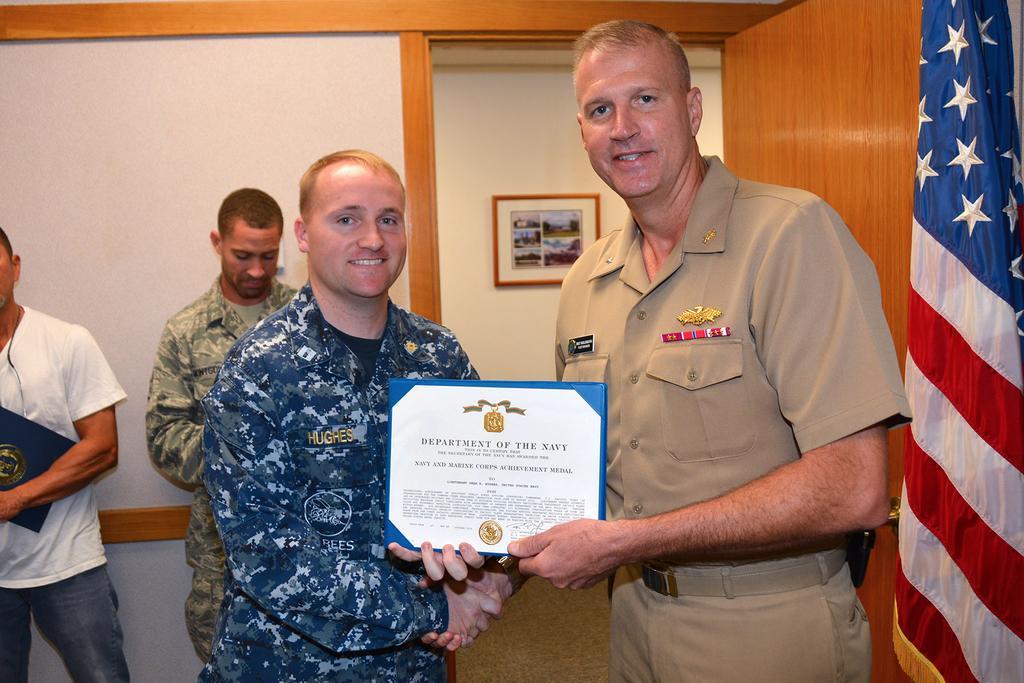Please provide a concise description of this image. In this image we can see a group of people standing on the ground, some persons are wearing uniforms. One person is holding a certificate with some text. To the left side of the image we can see a person holding a file. On the right side, we can see a flag. In the background, we can see a photo frame on the wall and a door. 